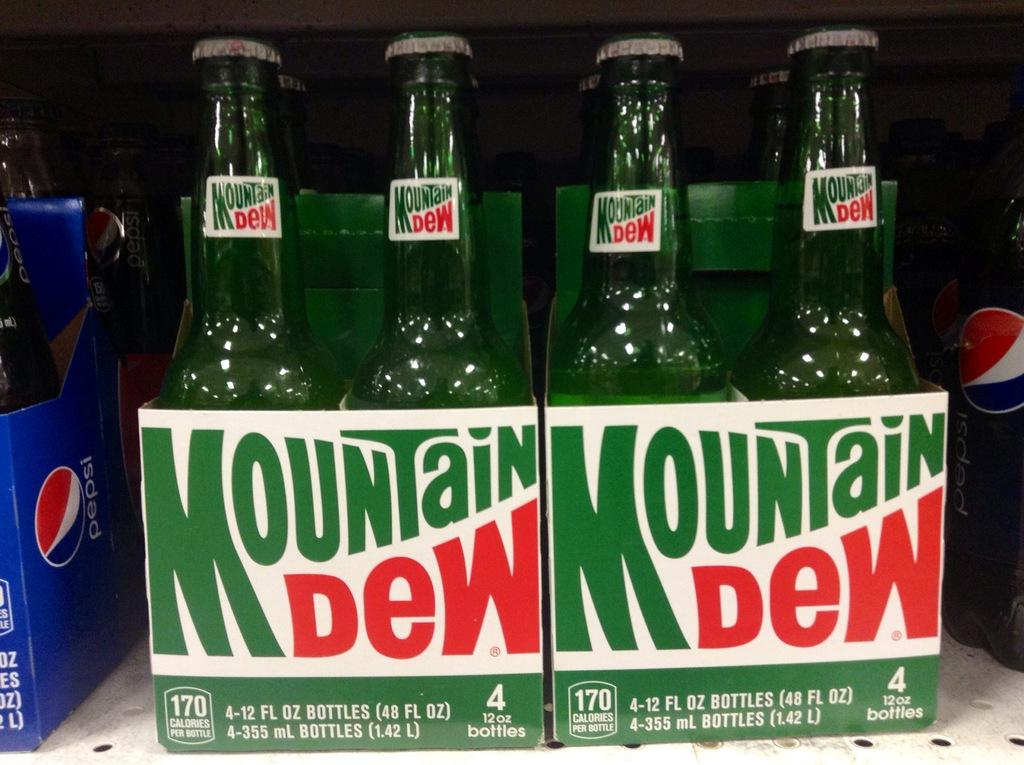<image>
Offer a succinct explanation of the picture presented. two cases of Mountain Dew sit next a case of pepsi 